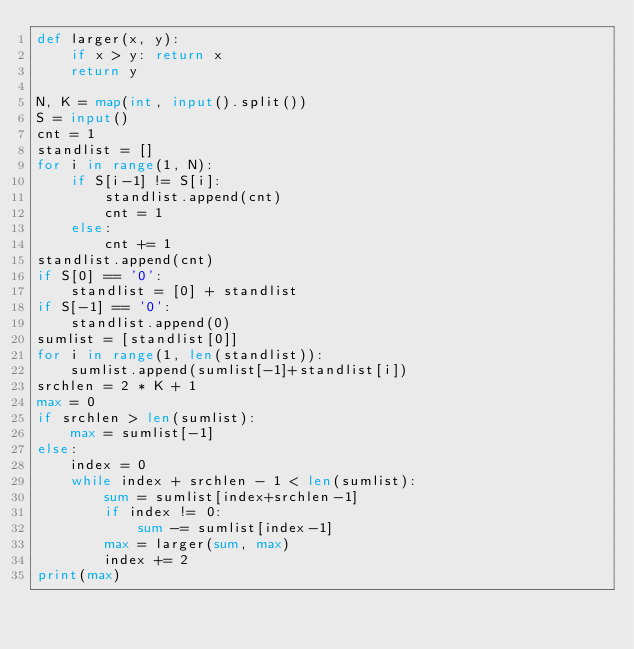<code> <loc_0><loc_0><loc_500><loc_500><_Python_>def larger(x, y):
	if x > y: return x
	return y

N, K = map(int, input().split())
S = input()
cnt = 1
standlist = []
for i in range(1, N):
	if S[i-1] != S[i]:
		standlist.append(cnt)
		cnt = 1
	else:
		cnt += 1
standlist.append(cnt)
if S[0] == '0':
	standlist = [0] + standlist
if S[-1] == '0':
	standlist.append(0)
sumlist = [standlist[0]]
for i in range(1, len(standlist)):
	sumlist.append(sumlist[-1]+standlist[i])
srchlen = 2 * K + 1
max = 0
if srchlen > len(sumlist):
	max = sumlist[-1]
else:
	index = 0
	while index + srchlen - 1 < len(sumlist):
		sum = sumlist[index+srchlen-1]
		if index != 0:
			sum -= sumlist[index-1]
		max = larger(sum, max)
		index += 2
print(max)</code> 